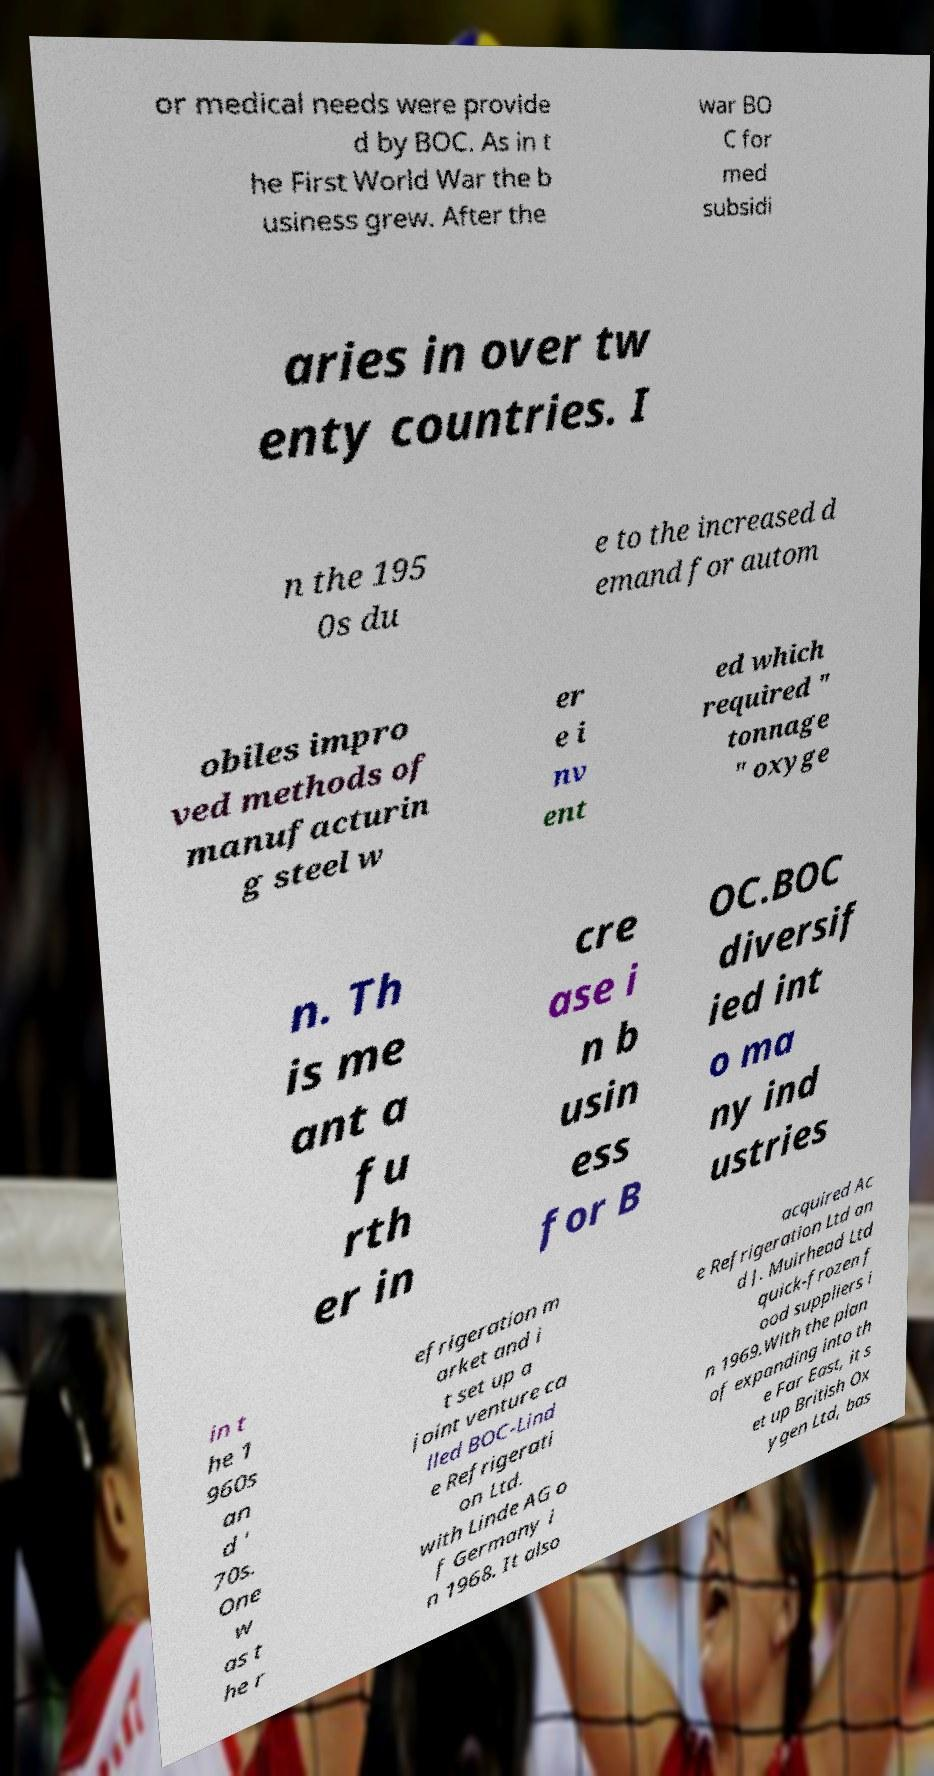Could you extract and type out the text from this image? or medical needs were provide d by BOC. As in t he First World War the b usiness grew. After the war BO C for med subsidi aries in over tw enty countries. I n the 195 0s du e to the increased d emand for autom obiles impro ved methods of manufacturin g steel w er e i nv ent ed which required " tonnage " oxyge n. Th is me ant a fu rth er in cre ase i n b usin ess for B OC.BOC diversif ied int o ma ny ind ustries in t he 1 960s an d ' 70s. One w as t he r efrigeration m arket and i t set up a joint venture ca lled BOC-Lind e Refrigerati on Ltd. with Linde AG o f Germany i n 1968. It also acquired Ac e Refrigeration Ltd an d J. Muirhead Ltd quick-frozen f ood suppliers i n 1969.With the plan of expanding into th e Far East, it s et up British Ox ygen Ltd, bas 